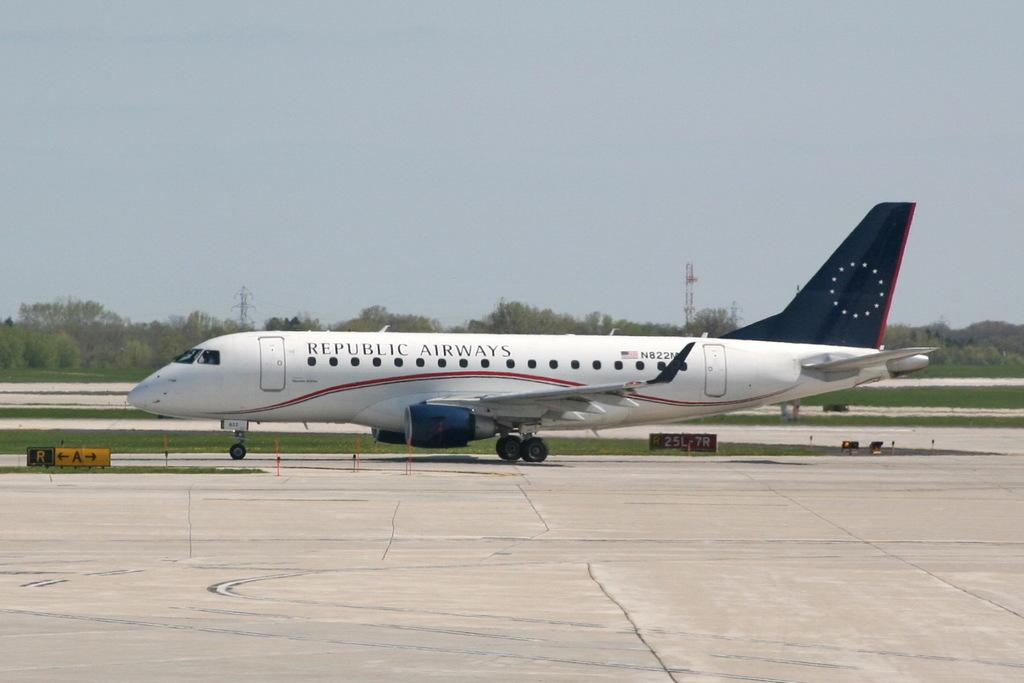<image>
Render a clear and concise summary of the photo. A Republic Airways is sitting on the tarmac on a sunny day. 